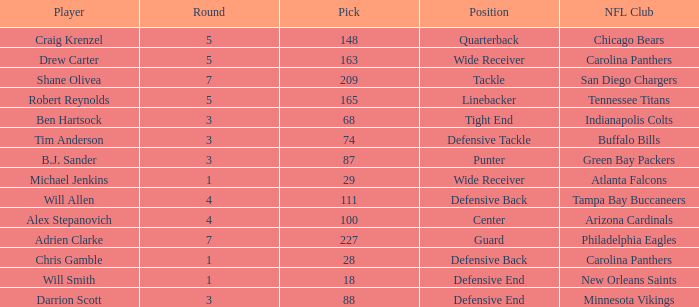What is the average Round number of Player Adrien Clarke? 7.0. 